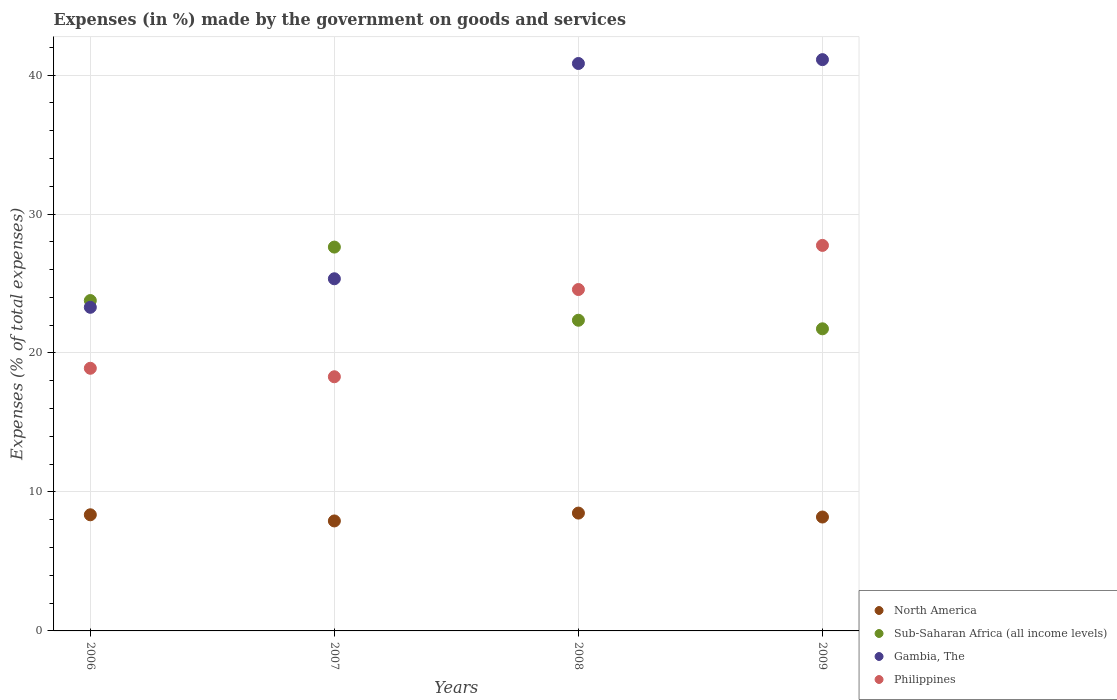How many different coloured dotlines are there?
Provide a succinct answer. 4. What is the percentage of expenses made by the government on goods and services in Sub-Saharan Africa (all income levels) in 2008?
Provide a succinct answer. 22.36. Across all years, what is the maximum percentage of expenses made by the government on goods and services in Philippines?
Provide a succinct answer. 27.74. Across all years, what is the minimum percentage of expenses made by the government on goods and services in Gambia, The?
Offer a very short reply. 23.29. In which year was the percentage of expenses made by the government on goods and services in North America minimum?
Offer a terse response. 2007. What is the total percentage of expenses made by the government on goods and services in Philippines in the graph?
Your answer should be compact. 89.5. What is the difference between the percentage of expenses made by the government on goods and services in Gambia, The in 2008 and that in 2009?
Keep it short and to the point. -0.28. What is the difference between the percentage of expenses made by the government on goods and services in North America in 2009 and the percentage of expenses made by the government on goods and services in Gambia, The in 2007?
Provide a short and direct response. -17.15. What is the average percentage of expenses made by the government on goods and services in North America per year?
Keep it short and to the point. 8.24. In the year 2007, what is the difference between the percentage of expenses made by the government on goods and services in North America and percentage of expenses made by the government on goods and services in Sub-Saharan Africa (all income levels)?
Your answer should be very brief. -19.71. What is the ratio of the percentage of expenses made by the government on goods and services in North America in 2006 to that in 2009?
Your answer should be very brief. 1.02. What is the difference between the highest and the second highest percentage of expenses made by the government on goods and services in North America?
Your response must be concise. 0.12. What is the difference between the highest and the lowest percentage of expenses made by the government on goods and services in Gambia, The?
Keep it short and to the point. 17.82. Is the sum of the percentage of expenses made by the government on goods and services in Gambia, The in 2007 and 2008 greater than the maximum percentage of expenses made by the government on goods and services in Sub-Saharan Africa (all income levels) across all years?
Your answer should be very brief. Yes. Is it the case that in every year, the sum of the percentage of expenses made by the government on goods and services in North America and percentage of expenses made by the government on goods and services in Sub-Saharan Africa (all income levels)  is greater than the sum of percentage of expenses made by the government on goods and services in Gambia, The and percentage of expenses made by the government on goods and services in Philippines?
Your answer should be compact. No. Is it the case that in every year, the sum of the percentage of expenses made by the government on goods and services in Philippines and percentage of expenses made by the government on goods and services in Gambia, The  is greater than the percentage of expenses made by the government on goods and services in North America?
Offer a terse response. Yes. Does the percentage of expenses made by the government on goods and services in Sub-Saharan Africa (all income levels) monotonically increase over the years?
Keep it short and to the point. No. How many dotlines are there?
Offer a terse response. 4. How many years are there in the graph?
Make the answer very short. 4. What is the difference between two consecutive major ticks on the Y-axis?
Offer a very short reply. 10. Are the values on the major ticks of Y-axis written in scientific E-notation?
Make the answer very short. No. Does the graph contain grids?
Offer a terse response. Yes. Where does the legend appear in the graph?
Give a very brief answer. Bottom right. How many legend labels are there?
Your answer should be compact. 4. What is the title of the graph?
Give a very brief answer. Expenses (in %) made by the government on goods and services. Does "Mauritania" appear as one of the legend labels in the graph?
Offer a very short reply. No. What is the label or title of the X-axis?
Ensure brevity in your answer.  Years. What is the label or title of the Y-axis?
Your answer should be very brief. Expenses (% of total expenses). What is the Expenses (% of total expenses) of North America in 2006?
Ensure brevity in your answer.  8.36. What is the Expenses (% of total expenses) of Sub-Saharan Africa (all income levels) in 2006?
Your response must be concise. 23.77. What is the Expenses (% of total expenses) in Gambia, The in 2006?
Give a very brief answer. 23.29. What is the Expenses (% of total expenses) of Philippines in 2006?
Ensure brevity in your answer.  18.9. What is the Expenses (% of total expenses) in North America in 2007?
Your answer should be compact. 7.91. What is the Expenses (% of total expenses) in Sub-Saharan Africa (all income levels) in 2007?
Offer a very short reply. 27.62. What is the Expenses (% of total expenses) of Gambia, The in 2007?
Offer a terse response. 25.34. What is the Expenses (% of total expenses) in Philippines in 2007?
Offer a very short reply. 18.29. What is the Expenses (% of total expenses) of North America in 2008?
Provide a short and direct response. 8.48. What is the Expenses (% of total expenses) in Sub-Saharan Africa (all income levels) in 2008?
Keep it short and to the point. 22.36. What is the Expenses (% of total expenses) in Gambia, The in 2008?
Offer a very short reply. 40.83. What is the Expenses (% of total expenses) of Philippines in 2008?
Offer a terse response. 24.57. What is the Expenses (% of total expenses) of North America in 2009?
Ensure brevity in your answer.  8.2. What is the Expenses (% of total expenses) of Sub-Saharan Africa (all income levels) in 2009?
Give a very brief answer. 21.74. What is the Expenses (% of total expenses) in Gambia, The in 2009?
Keep it short and to the point. 41.11. What is the Expenses (% of total expenses) in Philippines in 2009?
Your answer should be compact. 27.74. Across all years, what is the maximum Expenses (% of total expenses) of North America?
Provide a succinct answer. 8.48. Across all years, what is the maximum Expenses (% of total expenses) of Sub-Saharan Africa (all income levels)?
Give a very brief answer. 27.62. Across all years, what is the maximum Expenses (% of total expenses) of Gambia, The?
Your answer should be very brief. 41.11. Across all years, what is the maximum Expenses (% of total expenses) in Philippines?
Offer a terse response. 27.74. Across all years, what is the minimum Expenses (% of total expenses) of North America?
Make the answer very short. 7.91. Across all years, what is the minimum Expenses (% of total expenses) of Sub-Saharan Africa (all income levels)?
Your response must be concise. 21.74. Across all years, what is the minimum Expenses (% of total expenses) in Gambia, The?
Your response must be concise. 23.29. Across all years, what is the minimum Expenses (% of total expenses) of Philippines?
Keep it short and to the point. 18.29. What is the total Expenses (% of total expenses) of North America in the graph?
Give a very brief answer. 32.95. What is the total Expenses (% of total expenses) of Sub-Saharan Africa (all income levels) in the graph?
Your answer should be compact. 95.49. What is the total Expenses (% of total expenses) of Gambia, The in the graph?
Your answer should be compact. 130.57. What is the total Expenses (% of total expenses) of Philippines in the graph?
Ensure brevity in your answer.  89.5. What is the difference between the Expenses (% of total expenses) of North America in 2006 and that in 2007?
Your answer should be very brief. 0.44. What is the difference between the Expenses (% of total expenses) in Sub-Saharan Africa (all income levels) in 2006 and that in 2007?
Give a very brief answer. -3.85. What is the difference between the Expenses (% of total expenses) of Gambia, The in 2006 and that in 2007?
Your answer should be very brief. -2.05. What is the difference between the Expenses (% of total expenses) of Philippines in 2006 and that in 2007?
Your response must be concise. 0.61. What is the difference between the Expenses (% of total expenses) in North America in 2006 and that in 2008?
Your response must be concise. -0.12. What is the difference between the Expenses (% of total expenses) of Sub-Saharan Africa (all income levels) in 2006 and that in 2008?
Your response must be concise. 1.42. What is the difference between the Expenses (% of total expenses) in Gambia, The in 2006 and that in 2008?
Give a very brief answer. -17.55. What is the difference between the Expenses (% of total expenses) in Philippines in 2006 and that in 2008?
Provide a succinct answer. -5.67. What is the difference between the Expenses (% of total expenses) of North America in 2006 and that in 2009?
Provide a short and direct response. 0.16. What is the difference between the Expenses (% of total expenses) in Sub-Saharan Africa (all income levels) in 2006 and that in 2009?
Offer a very short reply. 2.03. What is the difference between the Expenses (% of total expenses) in Gambia, The in 2006 and that in 2009?
Offer a very short reply. -17.82. What is the difference between the Expenses (% of total expenses) of Philippines in 2006 and that in 2009?
Your answer should be very brief. -8.84. What is the difference between the Expenses (% of total expenses) in North America in 2007 and that in 2008?
Your answer should be very brief. -0.57. What is the difference between the Expenses (% of total expenses) in Sub-Saharan Africa (all income levels) in 2007 and that in 2008?
Your answer should be compact. 5.26. What is the difference between the Expenses (% of total expenses) of Gambia, The in 2007 and that in 2008?
Make the answer very short. -15.49. What is the difference between the Expenses (% of total expenses) of Philippines in 2007 and that in 2008?
Your answer should be compact. -6.28. What is the difference between the Expenses (% of total expenses) of North America in 2007 and that in 2009?
Your answer should be compact. -0.28. What is the difference between the Expenses (% of total expenses) in Sub-Saharan Africa (all income levels) in 2007 and that in 2009?
Offer a terse response. 5.88. What is the difference between the Expenses (% of total expenses) in Gambia, The in 2007 and that in 2009?
Give a very brief answer. -15.77. What is the difference between the Expenses (% of total expenses) in Philippines in 2007 and that in 2009?
Offer a terse response. -9.45. What is the difference between the Expenses (% of total expenses) of North America in 2008 and that in 2009?
Ensure brevity in your answer.  0.28. What is the difference between the Expenses (% of total expenses) of Sub-Saharan Africa (all income levels) in 2008 and that in 2009?
Keep it short and to the point. 0.62. What is the difference between the Expenses (% of total expenses) of Gambia, The in 2008 and that in 2009?
Make the answer very short. -0.28. What is the difference between the Expenses (% of total expenses) of Philippines in 2008 and that in 2009?
Provide a succinct answer. -3.18. What is the difference between the Expenses (% of total expenses) of North America in 2006 and the Expenses (% of total expenses) of Sub-Saharan Africa (all income levels) in 2007?
Your answer should be very brief. -19.26. What is the difference between the Expenses (% of total expenses) of North America in 2006 and the Expenses (% of total expenses) of Gambia, The in 2007?
Offer a terse response. -16.98. What is the difference between the Expenses (% of total expenses) in North America in 2006 and the Expenses (% of total expenses) in Philippines in 2007?
Offer a very short reply. -9.93. What is the difference between the Expenses (% of total expenses) of Sub-Saharan Africa (all income levels) in 2006 and the Expenses (% of total expenses) of Gambia, The in 2007?
Provide a succinct answer. -1.57. What is the difference between the Expenses (% of total expenses) of Sub-Saharan Africa (all income levels) in 2006 and the Expenses (% of total expenses) of Philippines in 2007?
Ensure brevity in your answer.  5.48. What is the difference between the Expenses (% of total expenses) in Gambia, The in 2006 and the Expenses (% of total expenses) in Philippines in 2007?
Give a very brief answer. 5. What is the difference between the Expenses (% of total expenses) in North America in 2006 and the Expenses (% of total expenses) in Sub-Saharan Africa (all income levels) in 2008?
Give a very brief answer. -14. What is the difference between the Expenses (% of total expenses) in North America in 2006 and the Expenses (% of total expenses) in Gambia, The in 2008?
Your answer should be compact. -32.48. What is the difference between the Expenses (% of total expenses) of North America in 2006 and the Expenses (% of total expenses) of Philippines in 2008?
Keep it short and to the point. -16.21. What is the difference between the Expenses (% of total expenses) of Sub-Saharan Africa (all income levels) in 2006 and the Expenses (% of total expenses) of Gambia, The in 2008?
Provide a short and direct response. -17.06. What is the difference between the Expenses (% of total expenses) of Sub-Saharan Africa (all income levels) in 2006 and the Expenses (% of total expenses) of Philippines in 2008?
Provide a succinct answer. -0.79. What is the difference between the Expenses (% of total expenses) of Gambia, The in 2006 and the Expenses (% of total expenses) of Philippines in 2008?
Your response must be concise. -1.28. What is the difference between the Expenses (% of total expenses) of North America in 2006 and the Expenses (% of total expenses) of Sub-Saharan Africa (all income levels) in 2009?
Your answer should be very brief. -13.38. What is the difference between the Expenses (% of total expenses) in North America in 2006 and the Expenses (% of total expenses) in Gambia, The in 2009?
Your answer should be compact. -32.75. What is the difference between the Expenses (% of total expenses) in North America in 2006 and the Expenses (% of total expenses) in Philippines in 2009?
Ensure brevity in your answer.  -19.39. What is the difference between the Expenses (% of total expenses) in Sub-Saharan Africa (all income levels) in 2006 and the Expenses (% of total expenses) in Gambia, The in 2009?
Keep it short and to the point. -17.34. What is the difference between the Expenses (% of total expenses) in Sub-Saharan Africa (all income levels) in 2006 and the Expenses (% of total expenses) in Philippines in 2009?
Ensure brevity in your answer.  -3.97. What is the difference between the Expenses (% of total expenses) in Gambia, The in 2006 and the Expenses (% of total expenses) in Philippines in 2009?
Make the answer very short. -4.46. What is the difference between the Expenses (% of total expenses) of North America in 2007 and the Expenses (% of total expenses) of Sub-Saharan Africa (all income levels) in 2008?
Offer a terse response. -14.44. What is the difference between the Expenses (% of total expenses) in North America in 2007 and the Expenses (% of total expenses) in Gambia, The in 2008?
Provide a succinct answer. -32.92. What is the difference between the Expenses (% of total expenses) in North America in 2007 and the Expenses (% of total expenses) in Philippines in 2008?
Your answer should be very brief. -16.65. What is the difference between the Expenses (% of total expenses) in Sub-Saharan Africa (all income levels) in 2007 and the Expenses (% of total expenses) in Gambia, The in 2008?
Ensure brevity in your answer.  -13.21. What is the difference between the Expenses (% of total expenses) of Sub-Saharan Africa (all income levels) in 2007 and the Expenses (% of total expenses) of Philippines in 2008?
Offer a very short reply. 3.05. What is the difference between the Expenses (% of total expenses) of Gambia, The in 2007 and the Expenses (% of total expenses) of Philippines in 2008?
Your answer should be compact. 0.77. What is the difference between the Expenses (% of total expenses) in North America in 2007 and the Expenses (% of total expenses) in Sub-Saharan Africa (all income levels) in 2009?
Provide a succinct answer. -13.83. What is the difference between the Expenses (% of total expenses) of North America in 2007 and the Expenses (% of total expenses) of Gambia, The in 2009?
Your response must be concise. -33.2. What is the difference between the Expenses (% of total expenses) of North America in 2007 and the Expenses (% of total expenses) of Philippines in 2009?
Your answer should be very brief. -19.83. What is the difference between the Expenses (% of total expenses) in Sub-Saharan Africa (all income levels) in 2007 and the Expenses (% of total expenses) in Gambia, The in 2009?
Give a very brief answer. -13.49. What is the difference between the Expenses (% of total expenses) of Sub-Saharan Africa (all income levels) in 2007 and the Expenses (% of total expenses) of Philippines in 2009?
Keep it short and to the point. -0.12. What is the difference between the Expenses (% of total expenses) in Gambia, The in 2007 and the Expenses (% of total expenses) in Philippines in 2009?
Provide a succinct answer. -2.4. What is the difference between the Expenses (% of total expenses) in North America in 2008 and the Expenses (% of total expenses) in Sub-Saharan Africa (all income levels) in 2009?
Ensure brevity in your answer.  -13.26. What is the difference between the Expenses (% of total expenses) in North America in 2008 and the Expenses (% of total expenses) in Gambia, The in 2009?
Offer a terse response. -32.63. What is the difference between the Expenses (% of total expenses) in North America in 2008 and the Expenses (% of total expenses) in Philippines in 2009?
Offer a terse response. -19.26. What is the difference between the Expenses (% of total expenses) of Sub-Saharan Africa (all income levels) in 2008 and the Expenses (% of total expenses) of Gambia, The in 2009?
Offer a terse response. -18.75. What is the difference between the Expenses (% of total expenses) in Sub-Saharan Africa (all income levels) in 2008 and the Expenses (% of total expenses) in Philippines in 2009?
Offer a terse response. -5.39. What is the difference between the Expenses (% of total expenses) of Gambia, The in 2008 and the Expenses (% of total expenses) of Philippines in 2009?
Your response must be concise. 13.09. What is the average Expenses (% of total expenses) of North America per year?
Ensure brevity in your answer.  8.24. What is the average Expenses (% of total expenses) in Sub-Saharan Africa (all income levels) per year?
Provide a short and direct response. 23.87. What is the average Expenses (% of total expenses) in Gambia, The per year?
Provide a succinct answer. 32.64. What is the average Expenses (% of total expenses) of Philippines per year?
Your answer should be very brief. 22.38. In the year 2006, what is the difference between the Expenses (% of total expenses) in North America and Expenses (% of total expenses) in Sub-Saharan Africa (all income levels)?
Offer a very short reply. -15.42. In the year 2006, what is the difference between the Expenses (% of total expenses) in North America and Expenses (% of total expenses) in Gambia, The?
Make the answer very short. -14.93. In the year 2006, what is the difference between the Expenses (% of total expenses) in North America and Expenses (% of total expenses) in Philippines?
Your answer should be compact. -10.54. In the year 2006, what is the difference between the Expenses (% of total expenses) in Sub-Saharan Africa (all income levels) and Expenses (% of total expenses) in Gambia, The?
Your answer should be compact. 0.49. In the year 2006, what is the difference between the Expenses (% of total expenses) in Sub-Saharan Africa (all income levels) and Expenses (% of total expenses) in Philippines?
Give a very brief answer. 4.87. In the year 2006, what is the difference between the Expenses (% of total expenses) of Gambia, The and Expenses (% of total expenses) of Philippines?
Offer a very short reply. 4.39. In the year 2007, what is the difference between the Expenses (% of total expenses) of North America and Expenses (% of total expenses) of Sub-Saharan Africa (all income levels)?
Your response must be concise. -19.71. In the year 2007, what is the difference between the Expenses (% of total expenses) of North America and Expenses (% of total expenses) of Gambia, The?
Offer a very short reply. -17.43. In the year 2007, what is the difference between the Expenses (% of total expenses) of North America and Expenses (% of total expenses) of Philippines?
Your response must be concise. -10.38. In the year 2007, what is the difference between the Expenses (% of total expenses) of Sub-Saharan Africa (all income levels) and Expenses (% of total expenses) of Gambia, The?
Provide a short and direct response. 2.28. In the year 2007, what is the difference between the Expenses (% of total expenses) of Sub-Saharan Africa (all income levels) and Expenses (% of total expenses) of Philippines?
Your answer should be compact. 9.33. In the year 2007, what is the difference between the Expenses (% of total expenses) in Gambia, The and Expenses (% of total expenses) in Philippines?
Provide a short and direct response. 7.05. In the year 2008, what is the difference between the Expenses (% of total expenses) of North America and Expenses (% of total expenses) of Sub-Saharan Africa (all income levels)?
Your answer should be compact. -13.88. In the year 2008, what is the difference between the Expenses (% of total expenses) in North America and Expenses (% of total expenses) in Gambia, The?
Offer a terse response. -32.35. In the year 2008, what is the difference between the Expenses (% of total expenses) in North America and Expenses (% of total expenses) in Philippines?
Offer a terse response. -16.09. In the year 2008, what is the difference between the Expenses (% of total expenses) in Sub-Saharan Africa (all income levels) and Expenses (% of total expenses) in Gambia, The?
Make the answer very short. -18.48. In the year 2008, what is the difference between the Expenses (% of total expenses) of Sub-Saharan Africa (all income levels) and Expenses (% of total expenses) of Philippines?
Offer a very short reply. -2.21. In the year 2008, what is the difference between the Expenses (% of total expenses) in Gambia, The and Expenses (% of total expenses) in Philippines?
Your answer should be very brief. 16.27. In the year 2009, what is the difference between the Expenses (% of total expenses) of North America and Expenses (% of total expenses) of Sub-Saharan Africa (all income levels)?
Keep it short and to the point. -13.54. In the year 2009, what is the difference between the Expenses (% of total expenses) in North America and Expenses (% of total expenses) in Gambia, The?
Your response must be concise. -32.91. In the year 2009, what is the difference between the Expenses (% of total expenses) in North America and Expenses (% of total expenses) in Philippines?
Provide a short and direct response. -19.55. In the year 2009, what is the difference between the Expenses (% of total expenses) of Sub-Saharan Africa (all income levels) and Expenses (% of total expenses) of Gambia, The?
Keep it short and to the point. -19.37. In the year 2009, what is the difference between the Expenses (% of total expenses) in Sub-Saharan Africa (all income levels) and Expenses (% of total expenses) in Philippines?
Give a very brief answer. -6. In the year 2009, what is the difference between the Expenses (% of total expenses) of Gambia, The and Expenses (% of total expenses) of Philippines?
Make the answer very short. 13.37. What is the ratio of the Expenses (% of total expenses) in North America in 2006 to that in 2007?
Make the answer very short. 1.06. What is the ratio of the Expenses (% of total expenses) of Sub-Saharan Africa (all income levels) in 2006 to that in 2007?
Keep it short and to the point. 0.86. What is the ratio of the Expenses (% of total expenses) in Gambia, The in 2006 to that in 2007?
Provide a short and direct response. 0.92. What is the ratio of the Expenses (% of total expenses) of Philippines in 2006 to that in 2007?
Make the answer very short. 1.03. What is the ratio of the Expenses (% of total expenses) of North America in 2006 to that in 2008?
Your response must be concise. 0.99. What is the ratio of the Expenses (% of total expenses) of Sub-Saharan Africa (all income levels) in 2006 to that in 2008?
Your response must be concise. 1.06. What is the ratio of the Expenses (% of total expenses) of Gambia, The in 2006 to that in 2008?
Your answer should be very brief. 0.57. What is the ratio of the Expenses (% of total expenses) of Philippines in 2006 to that in 2008?
Keep it short and to the point. 0.77. What is the ratio of the Expenses (% of total expenses) of North America in 2006 to that in 2009?
Give a very brief answer. 1.02. What is the ratio of the Expenses (% of total expenses) in Sub-Saharan Africa (all income levels) in 2006 to that in 2009?
Your answer should be compact. 1.09. What is the ratio of the Expenses (% of total expenses) of Gambia, The in 2006 to that in 2009?
Offer a terse response. 0.57. What is the ratio of the Expenses (% of total expenses) in Philippines in 2006 to that in 2009?
Offer a terse response. 0.68. What is the ratio of the Expenses (% of total expenses) of North America in 2007 to that in 2008?
Make the answer very short. 0.93. What is the ratio of the Expenses (% of total expenses) in Sub-Saharan Africa (all income levels) in 2007 to that in 2008?
Your answer should be compact. 1.24. What is the ratio of the Expenses (% of total expenses) of Gambia, The in 2007 to that in 2008?
Your answer should be very brief. 0.62. What is the ratio of the Expenses (% of total expenses) in Philippines in 2007 to that in 2008?
Your answer should be very brief. 0.74. What is the ratio of the Expenses (% of total expenses) of North America in 2007 to that in 2009?
Provide a succinct answer. 0.97. What is the ratio of the Expenses (% of total expenses) of Sub-Saharan Africa (all income levels) in 2007 to that in 2009?
Offer a terse response. 1.27. What is the ratio of the Expenses (% of total expenses) of Gambia, The in 2007 to that in 2009?
Give a very brief answer. 0.62. What is the ratio of the Expenses (% of total expenses) in Philippines in 2007 to that in 2009?
Give a very brief answer. 0.66. What is the ratio of the Expenses (% of total expenses) of North America in 2008 to that in 2009?
Offer a very short reply. 1.03. What is the ratio of the Expenses (% of total expenses) of Sub-Saharan Africa (all income levels) in 2008 to that in 2009?
Offer a terse response. 1.03. What is the ratio of the Expenses (% of total expenses) in Gambia, The in 2008 to that in 2009?
Offer a terse response. 0.99. What is the ratio of the Expenses (% of total expenses) in Philippines in 2008 to that in 2009?
Give a very brief answer. 0.89. What is the difference between the highest and the second highest Expenses (% of total expenses) in North America?
Offer a terse response. 0.12. What is the difference between the highest and the second highest Expenses (% of total expenses) in Sub-Saharan Africa (all income levels)?
Your response must be concise. 3.85. What is the difference between the highest and the second highest Expenses (% of total expenses) in Gambia, The?
Your answer should be compact. 0.28. What is the difference between the highest and the second highest Expenses (% of total expenses) in Philippines?
Provide a short and direct response. 3.18. What is the difference between the highest and the lowest Expenses (% of total expenses) in North America?
Your answer should be very brief. 0.57. What is the difference between the highest and the lowest Expenses (% of total expenses) of Sub-Saharan Africa (all income levels)?
Provide a short and direct response. 5.88. What is the difference between the highest and the lowest Expenses (% of total expenses) of Gambia, The?
Provide a succinct answer. 17.82. What is the difference between the highest and the lowest Expenses (% of total expenses) of Philippines?
Your response must be concise. 9.45. 